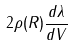Convert formula to latex. <formula><loc_0><loc_0><loc_500><loc_500>2 \rho ( R ) \frac { d \lambda } { d V }</formula> 